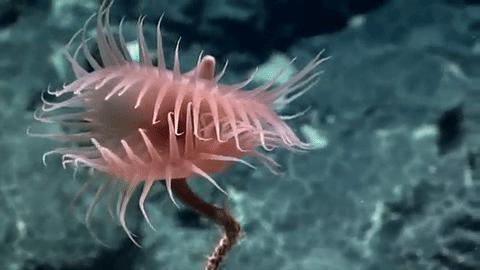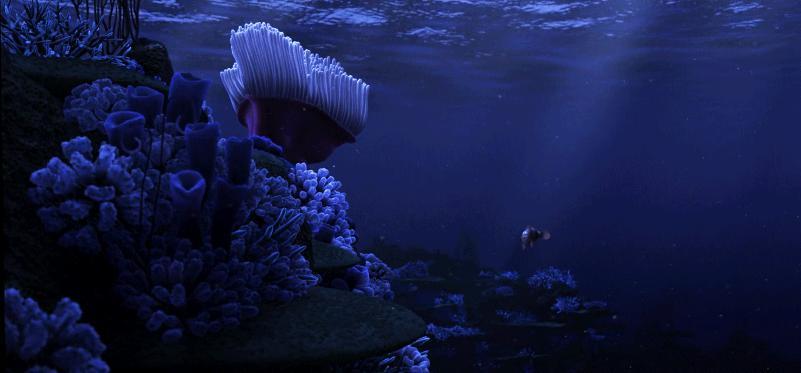The first image is the image on the left, the second image is the image on the right. Assess this claim about the two images: "The left image contains only pink anemone, and the right image includes an anemone with tendrils sprouting upward.". Correct or not? Answer yes or no. Yes. The first image is the image on the left, the second image is the image on the right. Given the left and right images, does the statement "The anemones in the left image is pink." hold true? Answer yes or no. Yes. 